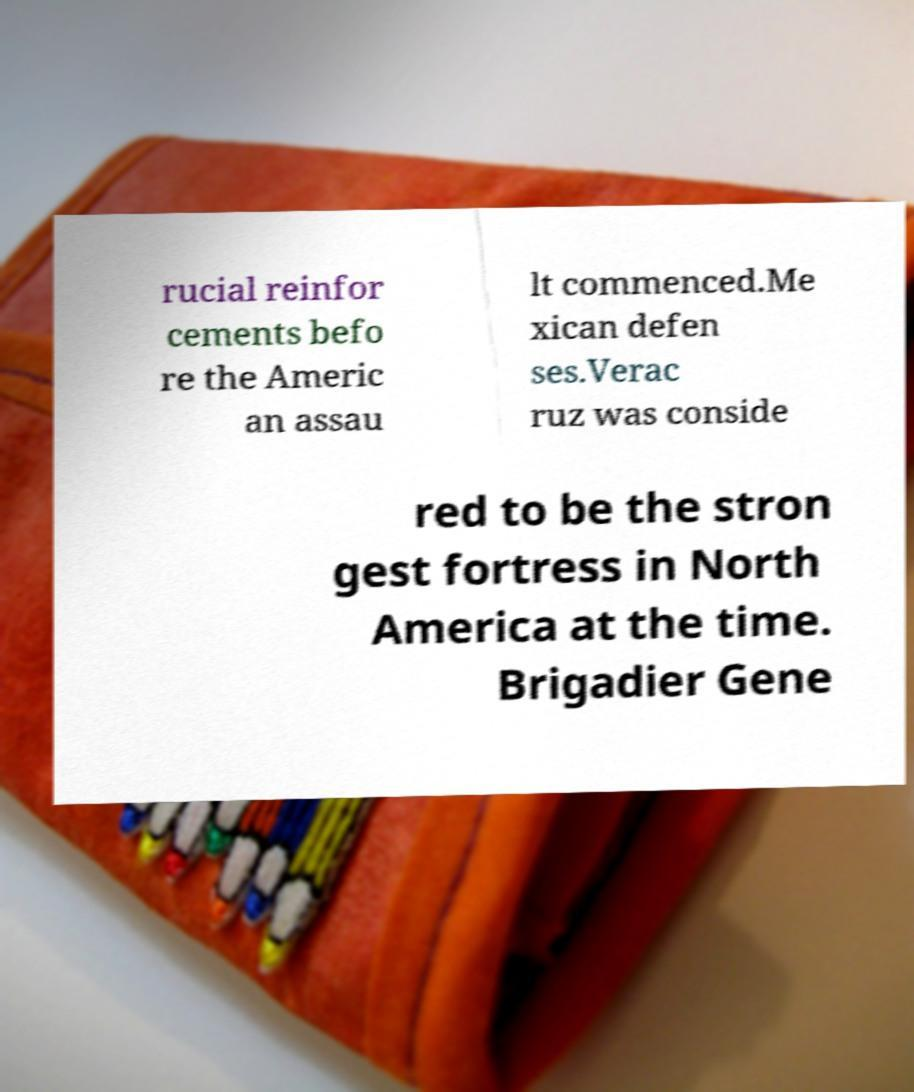There's text embedded in this image that I need extracted. Can you transcribe it verbatim? rucial reinfor cements befo re the Americ an assau lt commenced.Me xican defen ses.Verac ruz was conside red to be the stron gest fortress in North America at the time. Brigadier Gene 